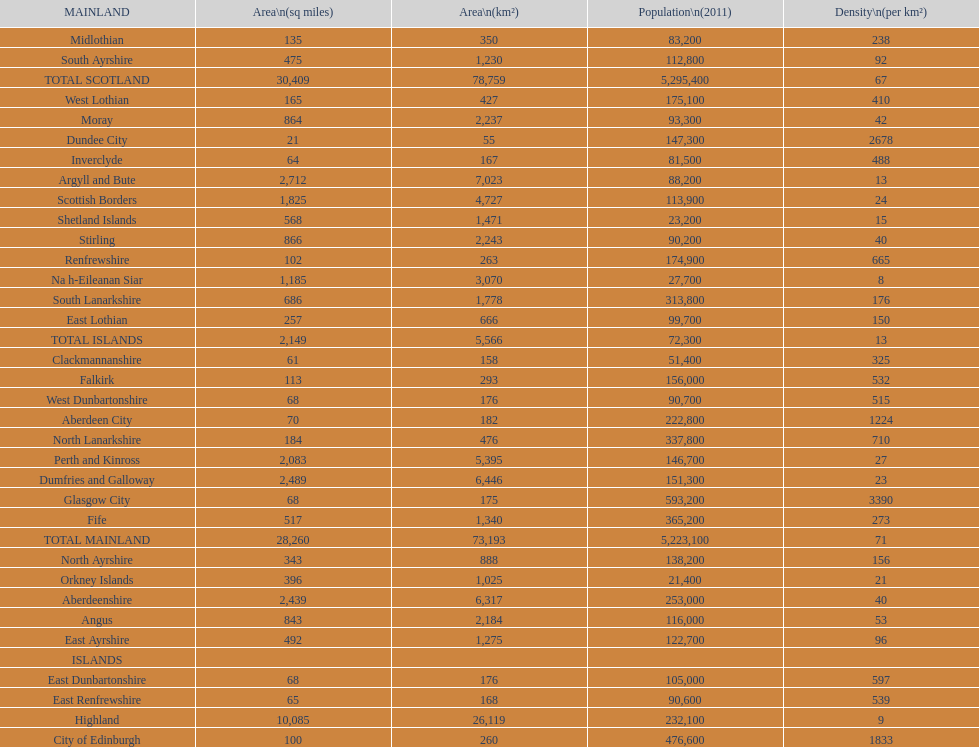What number of mainlands have populations under 100,000? 9. 